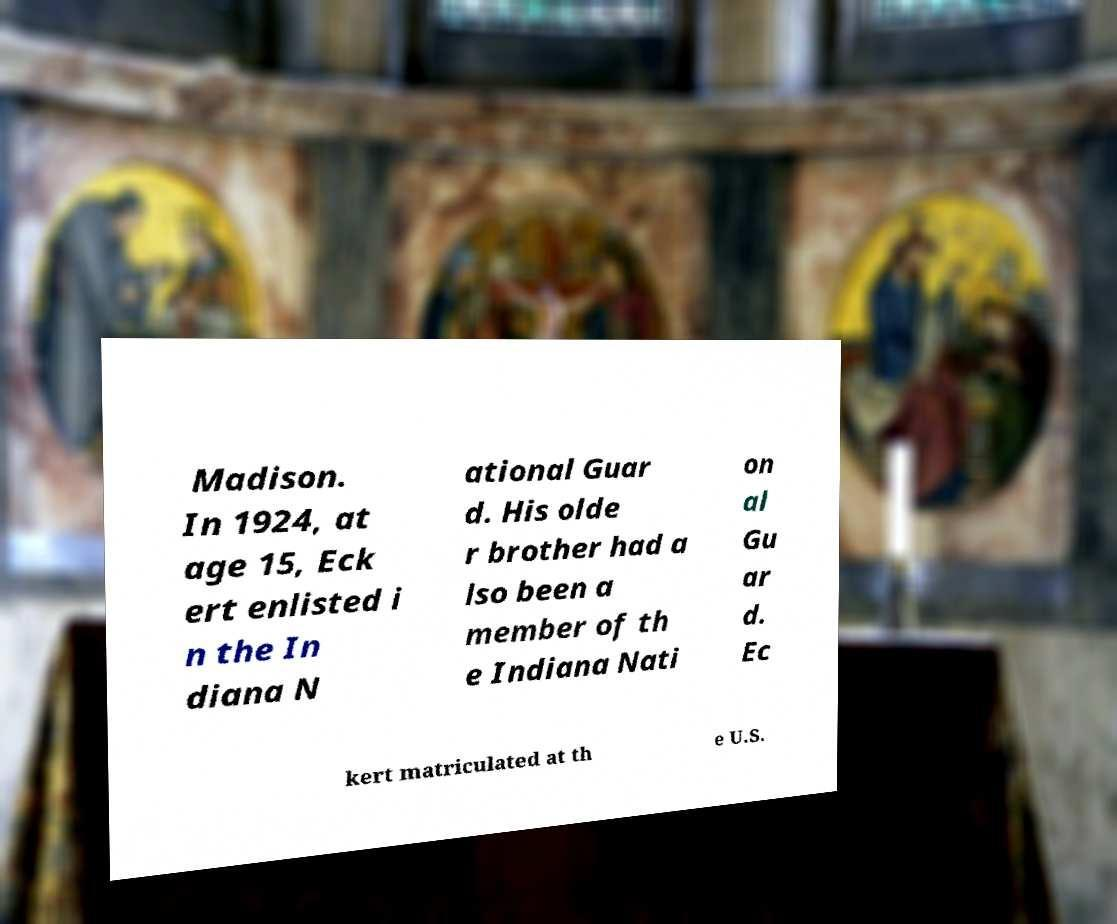Can you accurately transcribe the text from the provided image for me? Madison. In 1924, at age 15, Eck ert enlisted i n the In diana N ational Guar d. His olde r brother had a lso been a member of th e Indiana Nati on al Gu ar d. Ec kert matriculated at th e U.S. 